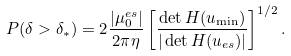Convert formula to latex. <formula><loc_0><loc_0><loc_500><loc_500>P ( \delta > \delta _ { * } ) = 2 \frac { | \mu _ { 0 } ^ { e s } | } { 2 \pi \eta } \left [ \frac { \det H ( { u } _ { \min } ) } { | \det H ( { u } _ { e s } ) | } \right ] ^ { 1 / 2 } .</formula> 